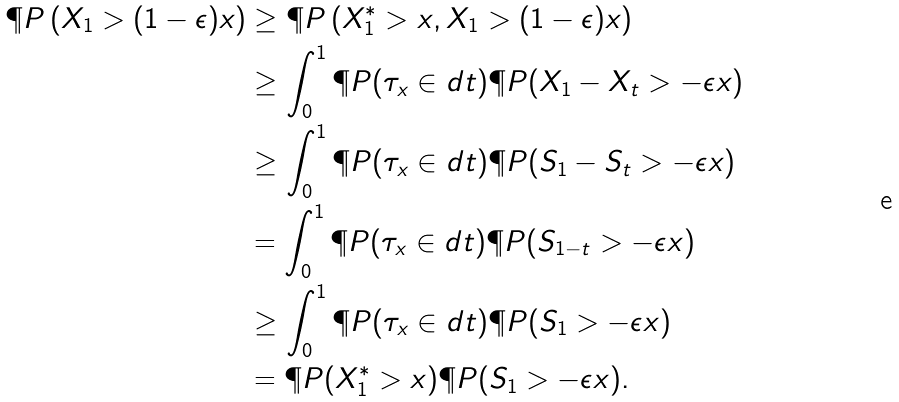<formula> <loc_0><loc_0><loc_500><loc_500>\P P \left ( X _ { 1 } > ( 1 - \epsilon ) x \right ) & \geq \P P \left ( X _ { 1 } ^ { * } > x , X _ { 1 } > ( 1 - \epsilon ) x \right ) \\ & \geq \int _ { 0 } ^ { 1 } \P P ( \tau _ { x } \in d t ) \P P ( X _ { 1 } - X _ { t } > - \epsilon x ) \\ & \geq \int _ { 0 } ^ { 1 } \P P ( \tau _ { x } \in d t ) \P P ( S _ { 1 } - S _ { t } > - \epsilon x ) \\ & = \int _ { 0 } ^ { 1 } \P P ( \tau _ { x } \in d t ) \P P ( S _ { 1 - t } > - \epsilon x ) \\ & \geq \int _ { 0 } ^ { 1 } \P P ( \tau _ { x } \in d t ) \P P ( S _ { 1 } > - \epsilon x ) \\ & = \P P ( X _ { 1 } ^ { * } > x ) \P P ( S _ { 1 } > - \epsilon x ) .</formula> 